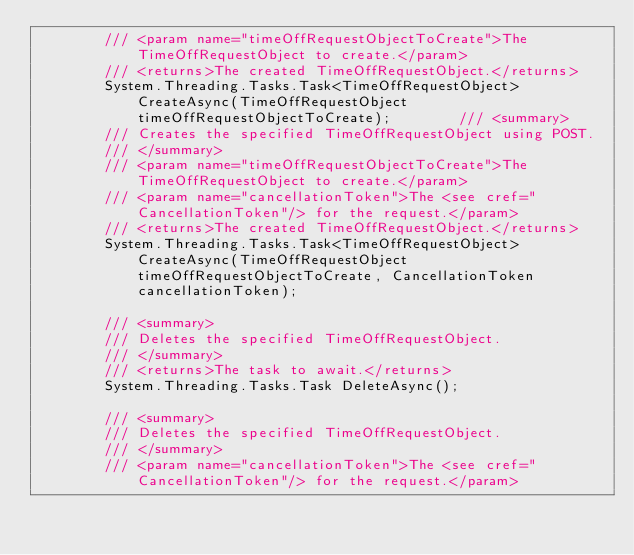Convert code to text. <code><loc_0><loc_0><loc_500><loc_500><_C#_>        /// <param name="timeOffRequestObjectToCreate">The TimeOffRequestObject to create.</param>
        /// <returns>The created TimeOffRequestObject.</returns>
        System.Threading.Tasks.Task<TimeOffRequestObject> CreateAsync(TimeOffRequestObject timeOffRequestObjectToCreate);        /// <summary>
        /// Creates the specified TimeOffRequestObject using POST.
        /// </summary>
        /// <param name="timeOffRequestObjectToCreate">The TimeOffRequestObject to create.</param>
        /// <param name="cancellationToken">The <see cref="CancellationToken"/> for the request.</param>
        /// <returns>The created TimeOffRequestObject.</returns>
        System.Threading.Tasks.Task<TimeOffRequestObject> CreateAsync(TimeOffRequestObject timeOffRequestObjectToCreate, CancellationToken cancellationToken);

        /// <summary>
        /// Deletes the specified TimeOffRequestObject.
        /// </summary>
        /// <returns>The task to await.</returns>
        System.Threading.Tasks.Task DeleteAsync();

        /// <summary>
        /// Deletes the specified TimeOffRequestObject.
        /// </summary>
        /// <param name="cancellationToken">The <see cref="CancellationToken"/> for the request.</param></code> 